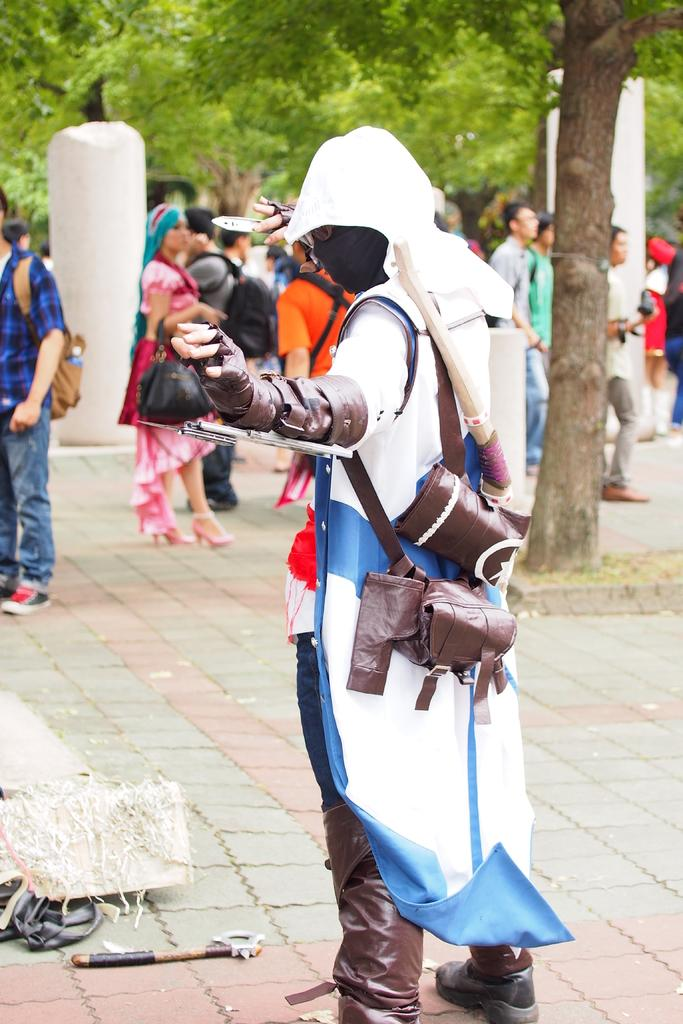What is happening in the middle of the image? There are people standing in the middle of the image. What can be seen in the background of the image? There are trees visible behind the people. What is located in the bottom left corner of the image? There are objects in the bottom left corner of the image. What type of thoughts can be seen in the image? There are no thoughts visible in the image; it features people standing and trees in the background. How many mice are present in the image? There are no mice present in the image. 